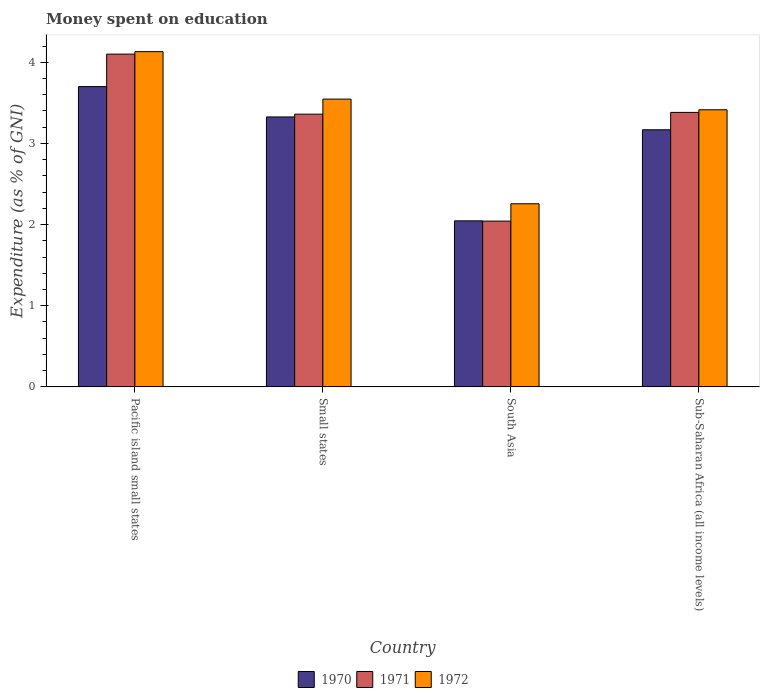How many different coloured bars are there?
Make the answer very short. 3. How many groups of bars are there?
Keep it short and to the point. 4. What is the label of the 4th group of bars from the left?
Ensure brevity in your answer.  Sub-Saharan Africa (all income levels). What is the amount of money spent on education in 1971 in South Asia?
Ensure brevity in your answer.  2.04. Across all countries, what is the maximum amount of money spent on education in 1972?
Your response must be concise. 4.13. Across all countries, what is the minimum amount of money spent on education in 1971?
Provide a short and direct response. 2.04. In which country was the amount of money spent on education in 1972 maximum?
Your answer should be very brief. Pacific island small states. What is the total amount of money spent on education in 1970 in the graph?
Your response must be concise. 12.24. What is the difference between the amount of money spent on education in 1972 in South Asia and that in Sub-Saharan Africa (all income levels)?
Your answer should be very brief. -1.16. What is the difference between the amount of money spent on education in 1970 in Sub-Saharan Africa (all income levels) and the amount of money spent on education in 1972 in Small states?
Ensure brevity in your answer.  -0.38. What is the average amount of money spent on education in 1972 per country?
Ensure brevity in your answer.  3.34. What is the difference between the amount of money spent on education of/in 1972 and amount of money spent on education of/in 1971 in Pacific island small states?
Your response must be concise. 0.03. What is the ratio of the amount of money spent on education in 1972 in Pacific island small states to that in South Asia?
Your answer should be compact. 1.83. Is the difference between the amount of money spent on education in 1972 in Small states and South Asia greater than the difference between the amount of money spent on education in 1971 in Small states and South Asia?
Make the answer very short. No. What is the difference between the highest and the second highest amount of money spent on education in 1972?
Give a very brief answer. -0.13. What is the difference between the highest and the lowest amount of money spent on education in 1970?
Offer a terse response. 1.65. Is it the case that in every country, the sum of the amount of money spent on education in 1970 and amount of money spent on education in 1972 is greater than the amount of money spent on education in 1971?
Your response must be concise. Yes. Are all the bars in the graph horizontal?
Offer a very short reply. No. How many countries are there in the graph?
Give a very brief answer. 4. What is the difference between two consecutive major ticks on the Y-axis?
Your answer should be compact. 1. Does the graph contain any zero values?
Offer a very short reply. No. Does the graph contain grids?
Your answer should be very brief. No. What is the title of the graph?
Provide a short and direct response. Money spent on education. What is the label or title of the X-axis?
Provide a succinct answer. Country. What is the label or title of the Y-axis?
Keep it short and to the point. Expenditure (as % of GNI). What is the Expenditure (as % of GNI) of 1972 in Pacific island small states?
Your response must be concise. 4.13. What is the Expenditure (as % of GNI) in 1970 in Small states?
Provide a succinct answer. 3.33. What is the Expenditure (as % of GNI) of 1971 in Small states?
Your answer should be very brief. 3.36. What is the Expenditure (as % of GNI) of 1972 in Small states?
Provide a short and direct response. 3.55. What is the Expenditure (as % of GNI) in 1970 in South Asia?
Offer a very short reply. 2.05. What is the Expenditure (as % of GNI) of 1971 in South Asia?
Offer a terse response. 2.04. What is the Expenditure (as % of GNI) of 1972 in South Asia?
Offer a terse response. 2.26. What is the Expenditure (as % of GNI) of 1970 in Sub-Saharan Africa (all income levels)?
Keep it short and to the point. 3.17. What is the Expenditure (as % of GNI) in 1971 in Sub-Saharan Africa (all income levels)?
Offer a very short reply. 3.38. What is the Expenditure (as % of GNI) in 1972 in Sub-Saharan Africa (all income levels)?
Offer a very short reply. 3.41. Across all countries, what is the maximum Expenditure (as % of GNI) of 1970?
Offer a very short reply. 3.7. Across all countries, what is the maximum Expenditure (as % of GNI) in 1971?
Make the answer very short. 4.1. Across all countries, what is the maximum Expenditure (as % of GNI) in 1972?
Ensure brevity in your answer.  4.13. Across all countries, what is the minimum Expenditure (as % of GNI) of 1970?
Your answer should be compact. 2.05. Across all countries, what is the minimum Expenditure (as % of GNI) in 1971?
Your response must be concise. 2.04. Across all countries, what is the minimum Expenditure (as % of GNI) of 1972?
Offer a terse response. 2.26. What is the total Expenditure (as % of GNI) in 1970 in the graph?
Your answer should be compact. 12.24. What is the total Expenditure (as % of GNI) in 1971 in the graph?
Your answer should be very brief. 12.88. What is the total Expenditure (as % of GNI) in 1972 in the graph?
Provide a succinct answer. 13.35. What is the difference between the Expenditure (as % of GNI) of 1970 in Pacific island small states and that in Small states?
Make the answer very short. 0.37. What is the difference between the Expenditure (as % of GNI) of 1971 in Pacific island small states and that in Small states?
Give a very brief answer. 0.74. What is the difference between the Expenditure (as % of GNI) in 1972 in Pacific island small states and that in Small states?
Offer a terse response. 0.58. What is the difference between the Expenditure (as % of GNI) of 1970 in Pacific island small states and that in South Asia?
Provide a succinct answer. 1.65. What is the difference between the Expenditure (as % of GNI) of 1971 in Pacific island small states and that in South Asia?
Your response must be concise. 2.06. What is the difference between the Expenditure (as % of GNI) in 1972 in Pacific island small states and that in South Asia?
Offer a very short reply. 1.87. What is the difference between the Expenditure (as % of GNI) of 1970 in Pacific island small states and that in Sub-Saharan Africa (all income levels)?
Make the answer very short. 0.53. What is the difference between the Expenditure (as % of GNI) in 1971 in Pacific island small states and that in Sub-Saharan Africa (all income levels)?
Your answer should be very brief. 0.72. What is the difference between the Expenditure (as % of GNI) of 1972 in Pacific island small states and that in Sub-Saharan Africa (all income levels)?
Give a very brief answer. 0.72. What is the difference between the Expenditure (as % of GNI) of 1970 in Small states and that in South Asia?
Give a very brief answer. 1.28. What is the difference between the Expenditure (as % of GNI) of 1971 in Small states and that in South Asia?
Ensure brevity in your answer.  1.32. What is the difference between the Expenditure (as % of GNI) in 1972 in Small states and that in South Asia?
Your answer should be very brief. 1.29. What is the difference between the Expenditure (as % of GNI) in 1970 in Small states and that in Sub-Saharan Africa (all income levels)?
Ensure brevity in your answer.  0.16. What is the difference between the Expenditure (as % of GNI) of 1971 in Small states and that in Sub-Saharan Africa (all income levels)?
Keep it short and to the point. -0.02. What is the difference between the Expenditure (as % of GNI) of 1972 in Small states and that in Sub-Saharan Africa (all income levels)?
Give a very brief answer. 0.13. What is the difference between the Expenditure (as % of GNI) in 1970 in South Asia and that in Sub-Saharan Africa (all income levels)?
Keep it short and to the point. -1.12. What is the difference between the Expenditure (as % of GNI) of 1971 in South Asia and that in Sub-Saharan Africa (all income levels)?
Give a very brief answer. -1.34. What is the difference between the Expenditure (as % of GNI) of 1972 in South Asia and that in Sub-Saharan Africa (all income levels)?
Your answer should be very brief. -1.16. What is the difference between the Expenditure (as % of GNI) in 1970 in Pacific island small states and the Expenditure (as % of GNI) in 1971 in Small states?
Your response must be concise. 0.34. What is the difference between the Expenditure (as % of GNI) in 1970 in Pacific island small states and the Expenditure (as % of GNI) in 1972 in Small states?
Provide a succinct answer. 0.15. What is the difference between the Expenditure (as % of GNI) in 1971 in Pacific island small states and the Expenditure (as % of GNI) in 1972 in Small states?
Your response must be concise. 0.55. What is the difference between the Expenditure (as % of GNI) of 1970 in Pacific island small states and the Expenditure (as % of GNI) of 1971 in South Asia?
Your answer should be compact. 1.66. What is the difference between the Expenditure (as % of GNI) of 1970 in Pacific island small states and the Expenditure (as % of GNI) of 1972 in South Asia?
Your answer should be compact. 1.44. What is the difference between the Expenditure (as % of GNI) in 1971 in Pacific island small states and the Expenditure (as % of GNI) in 1972 in South Asia?
Your response must be concise. 1.84. What is the difference between the Expenditure (as % of GNI) of 1970 in Pacific island small states and the Expenditure (as % of GNI) of 1971 in Sub-Saharan Africa (all income levels)?
Keep it short and to the point. 0.32. What is the difference between the Expenditure (as % of GNI) in 1970 in Pacific island small states and the Expenditure (as % of GNI) in 1972 in Sub-Saharan Africa (all income levels)?
Offer a terse response. 0.29. What is the difference between the Expenditure (as % of GNI) in 1971 in Pacific island small states and the Expenditure (as % of GNI) in 1972 in Sub-Saharan Africa (all income levels)?
Your answer should be very brief. 0.69. What is the difference between the Expenditure (as % of GNI) in 1970 in Small states and the Expenditure (as % of GNI) in 1971 in South Asia?
Your answer should be very brief. 1.28. What is the difference between the Expenditure (as % of GNI) of 1970 in Small states and the Expenditure (as % of GNI) of 1972 in South Asia?
Make the answer very short. 1.07. What is the difference between the Expenditure (as % of GNI) in 1971 in Small states and the Expenditure (as % of GNI) in 1972 in South Asia?
Make the answer very short. 1.1. What is the difference between the Expenditure (as % of GNI) in 1970 in Small states and the Expenditure (as % of GNI) in 1971 in Sub-Saharan Africa (all income levels)?
Make the answer very short. -0.06. What is the difference between the Expenditure (as % of GNI) in 1970 in Small states and the Expenditure (as % of GNI) in 1972 in Sub-Saharan Africa (all income levels)?
Your response must be concise. -0.09. What is the difference between the Expenditure (as % of GNI) of 1971 in Small states and the Expenditure (as % of GNI) of 1972 in Sub-Saharan Africa (all income levels)?
Make the answer very short. -0.05. What is the difference between the Expenditure (as % of GNI) in 1970 in South Asia and the Expenditure (as % of GNI) in 1971 in Sub-Saharan Africa (all income levels)?
Your response must be concise. -1.34. What is the difference between the Expenditure (as % of GNI) in 1970 in South Asia and the Expenditure (as % of GNI) in 1972 in Sub-Saharan Africa (all income levels)?
Your answer should be very brief. -1.37. What is the difference between the Expenditure (as % of GNI) in 1971 in South Asia and the Expenditure (as % of GNI) in 1972 in Sub-Saharan Africa (all income levels)?
Your answer should be compact. -1.37. What is the average Expenditure (as % of GNI) in 1970 per country?
Your answer should be very brief. 3.06. What is the average Expenditure (as % of GNI) in 1971 per country?
Your answer should be very brief. 3.22. What is the average Expenditure (as % of GNI) in 1972 per country?
Your answer should be compact. 3.34. What is the difference between the Expenditure (as % of GNI) in 1970 and Expenditure (as % of GNI) in 1971 in Pacific island small states?
Provide a short and direct response. -0.4. What is the difference between the Expenditure (as % of GNI) of 1970 and Expenditure (as % of GNI) of 1972 in Pacific island small states?
Your response must be concise. -0.43. What is the difference between the Expenditure (as % of GNI) of 1971 and Expenditure (as % of GNI) of 1972 in Pacific island small states?
Your answer should be compact. -0.03. What is the difference between the Expenditure (as % of GNI) of 1970 and Expenditure (as % of GNI) of 1971 in Small states?
Your answer should be very brief. -0.03. What is the difference between the Expenditure (as % of GNI) of 1970 and Expenditure (as % of GNI) of 1972 in Small states?
Offer a terse response. -0.22. What is the difference between the Expenditure (as % of GNI) in 1971 and Expenditure (as % of GNI) in 1972 in Small states?
Your answer should be compact. -0.19. What is the difference between the Expenditure (as % of GNI) in 1970 and Expenditure (as % of GNI) in 1971 in South Asia?
Your answer should be compact. 0. What is the difference between the Expenditure (as % of GNI) in 1970 and Expenditure (as % of GNI) in 1972 in South Asia?
Your response must be concise. -0.21. What is the difference between the Expenditure (as % of GNI) in 1971 and Expenditure (as % of GNI) in 1972 in South Asia?
Keep it short and to the point. -0.21. What is the difference between the Expenditure (as % of GNI) in 1970 and Expenditure (as % of GNI) in 1971 in Sub-Saharan Africa (all income levels)?
Make the answer very short. -0.21. What is the difference between the Expenditure (as % of GNI) of 1970 and Expenditure (as % of GNI) of 1972 in Sub-Saharan Africa (all income levels)?
Provide a succinct answer. -0.25. What is the difference between the Expenditure (as % of GNI) in 1971 and Expenditure (as % of GNI) in 1972 in Sub-Saharan Africa (all income levels)?
Provide a short and direct response. -0.03. What is the ratio of the Expenditure (as % of GNI) in 1970 in Pacific island small states to that in Small states?
Your answer should be very brief. 1.11. What is the ratio of the Expenditure (as % of GNI) in 1971 in Pacific island small states to that in Small states?
Provide a succinct answer. 1.22. What is the ratio of the Expenditure (as % of GNI) in 1972 in Pacific island small states to that in Small states?
Provide a succinct answer. 1.16. What is the ratio of the Expenditure (as % of GNI) in 1970 in Pacific island small states to that in South Asia?
Make the answer very short. 1.81. What is the ratio of the Expenditure (as % of GNI) of 1971 in Pacific island small states to that in South Asia?
Make the answer very short. 2.01. What is the ratio of the Expenditure (as % of GNI) of 1972 in Pacific island small states to that in South Asia?
Your response must be concise. 1.83. What is the ratio of the Expenditure (as % of GNI) of 1970 in Pacific island small states to that in Sub-Saharan Africa (all income levels)?
Ensure brevity in your answer.  1.17. What is the ratio of the Expenditure (as % of GNI) of 1971 in Pacific island small states to that in Sub-Saharan Africa (all income levels)?
Provide a succinct answer. 1.21. What is the ratio of the Expenditure (as % of GNI) in 1972 in Pacific island small states to that in Sub-Saharan Africa (all income levels)?
Make the answer very short. 1.21. What is the ratio of the Expenditure (as % of GNI) in 1970 in Small states to that in South Asia?
Your answer should be very brief. 1.63. What is the ratio of the Expenditure (as % of GNI) of 1971 in Small states to that in South Asia?
Keep it short and to the point. 1.65. What is the ratio of the Expenditure (as % of GNI) of 1972 in Small states to that in South Asia?
Offer a terse response. 1.57. What is the ratio of the Expenditure (as % of GNI) of 1970 in Small states to that in Sub-Saharan Africa (all income levels)?
Provide a short and direct response. 1.05. What is the ratio of the Expenditure (as % of GNI) of 1972 in Small states to that in Sub-Saharan Africa (all income levels)?
Provide a succinct answer. 1.04. What is the ratio of the Expenditure (as % of GNI) of 1970 in South Asia to that in Sub-Saharan Africa (all income levels)?
Provide a succinct answer. 0.65. What is the ratio of the Expenditure (as % of GNI) in 1971 in South Asia to that in Sub-Saharan Africa (all income levels)?
Offer a terse response. 0.6. What is the ratio of the Expenditure (as % of GNI) in 1972 in South Asia to that in Sub-Saharan Africa (all income levels)?
Keep it short and to the point. 0.66. What is the difference between the highest and the second highest Expenditure (as % of GNI) of 1970?
Your response must be concise. 0.37. What is the difference between the highest and the second highest Expenditure (as % of GNI) in 1971?
Make the answer very short. 0.72. What is the difference between the highest and the second highest Expenditure (as % of GNI) of 1972?
Provide a short and direct response. 0.58. What is the difference between the highest and the lowest Expenditure (as % of GNI) of 1970?
Offer a very short reply. 1.65. What is the difference between the highest and the lowest Expenditure (as % of GNI) of 1971?
Ensure brevity in your answer.  2.06. What is the difference between the highest and the lowest Expenditure (as % of GNI) of 1972?
Make the answer very short. 1.87. 